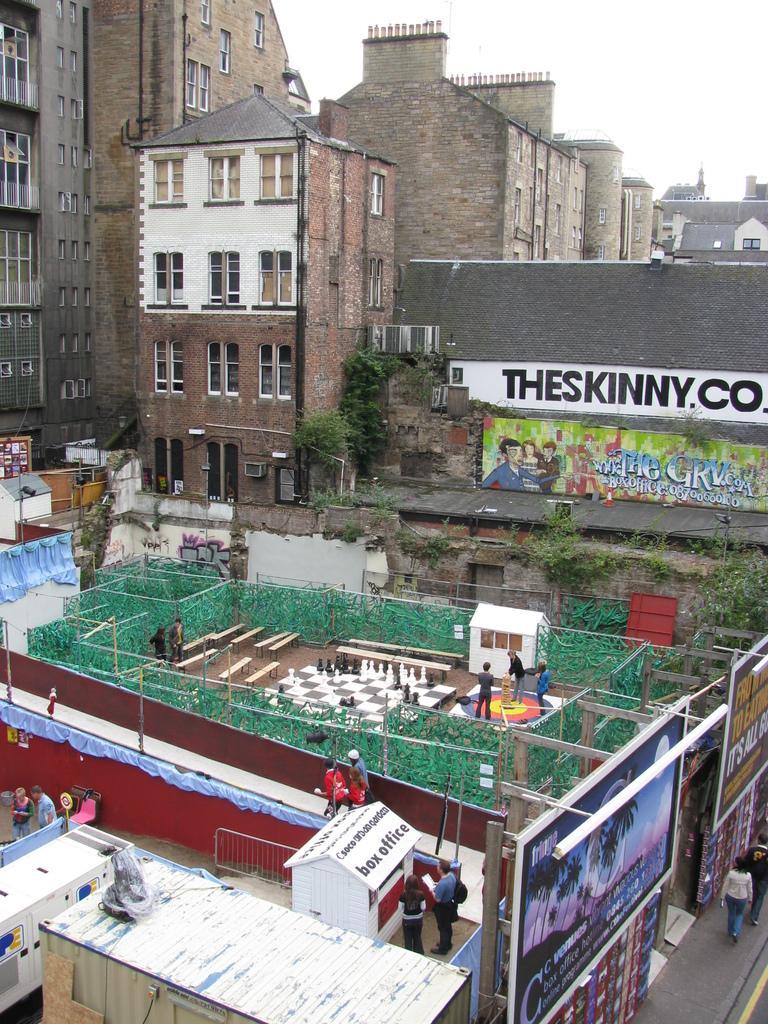In one or two sentences, can you explain what this image depicts? In this picture there is a model of chess on the terrace and there are people in the image and there are posters on the wall and there are buildings in the background area of the image and trees in the image. 